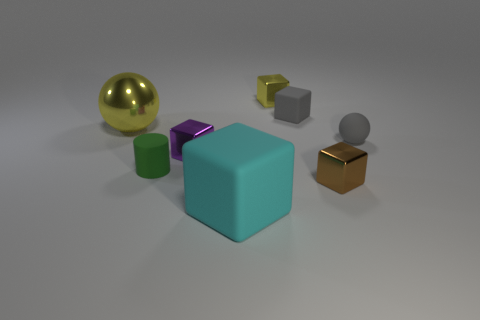There is a big ball; is its color the same as the small metallic block that is behind the tiny gray matte block?
Ensure brevity in your answer.  Yes. How many other large rubber blocks are the same color as the big rubber block?
Make the answer very short. 0. What is the material of the ball to the right of the large thing to the right of the metal sphere?
Your answer should be compact. Rubber. What is the size of the cyan cube?
Your response must be concise. Large. How many rubber things have the same size as the shiny ball?
Your response must be concise. 1. How many small purple metal objects have the same shape as the tiny brown metal thing?
Your answer should be very brief. 1. Are there an equal number of shiny balls in front of the shiny sphere and tiny yellow cubes?
Give a very brief answer. No. There is a yellow metal object that is the same size as the cyan rubber block; what is its shape?
Ensure brevity in your answer.  Sphere. Is there another large matte object that has the same shape as the brown object?
Ensure brevity in your answer.  Yes. There is a yellow object behind the shiny thing on the left side of the green cylinder; is there a tiny cube that is in front of it?
Your answer should be compact. Yes. 